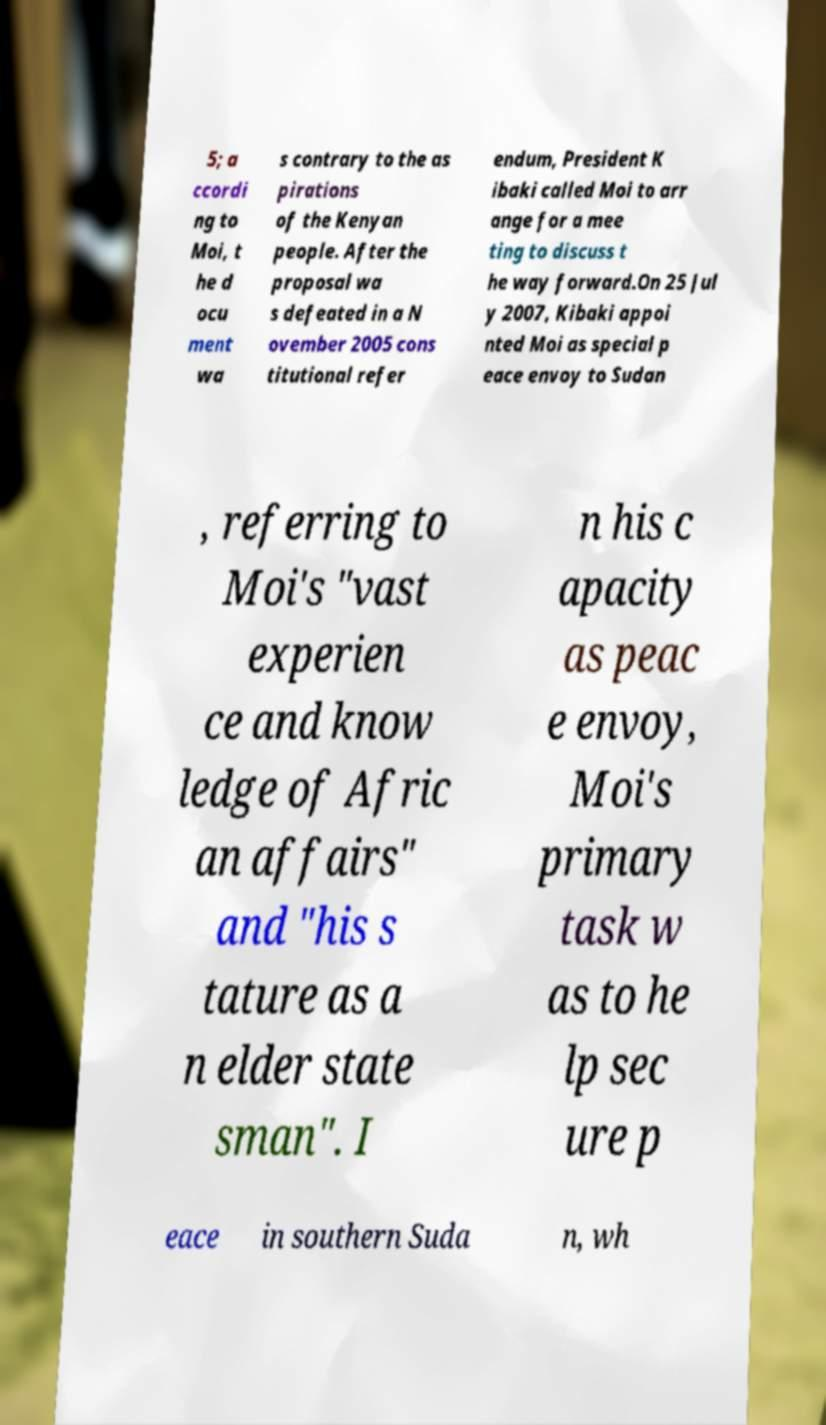Could you assist in decoding the text presented in this image and type it out clearly? 5; a ccordi ng to Moi, t he d ocu ment wa s contrary to the as pirations of the Kenyan people. After the proposal wa s defeated in a N ovember 2005 cons titutional refer endum, President K ibaki called Moi to arr ange for a mee ting to discuss t he way forward.On 25 Jul y 2007, Kibaki appoi nted Moi as special p eace envoy to Sudan , referring to Moi's "vast experien ce and know ledge of Afric an affairs" and "his s tature as a n elder state sman". I n his c apacity as peac e envoy, Moi's primary task w as to he lp sec ure p eace in southern Suda n, wh 